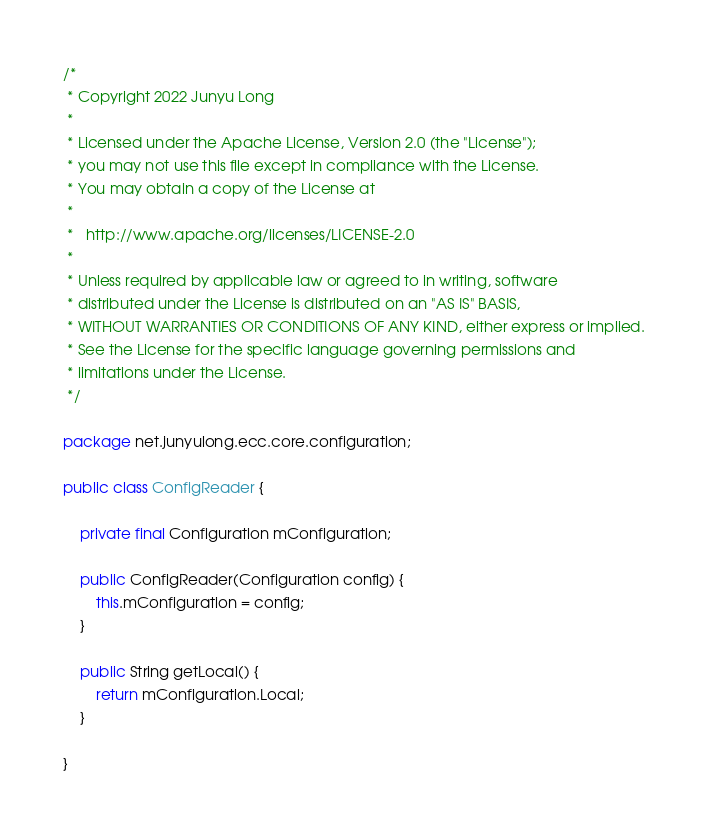Convert code to text. <code><loc_0><loc_0><loc_500><loc_500><_Java_>/*
 * Copyright 2022 Junyu Long
 *
 * Licensed under the Apache License, Version 2.0 (the "License");
 * you may not use this file except in compliance with the License.
 * You may obtain a copy of the License at
 *
 *   http://www.apache.org/licenses/LICENSE-2.0
 *
 * Unless required by applicable law or agreed to in writing, software
 * distributed under the License is distributed on an "AS IS" BASIS,
 * WITHOUT WARRANTIES OR CONDITIONS OF ANY KIND, either express or implied.
 * See the License for the specific language governing permissions and
 * limitations under the License.
 */

package net.junyulong.ecc.core.configuration;

public class ConfigReader {

    private final Configuration mConfiguration;

    public ConfigReader(Configuration config) {
        this.mConfiguration = config;
    }

    public String getLocal() {
        return mConfiguration.Local;
    }

}
</code> 